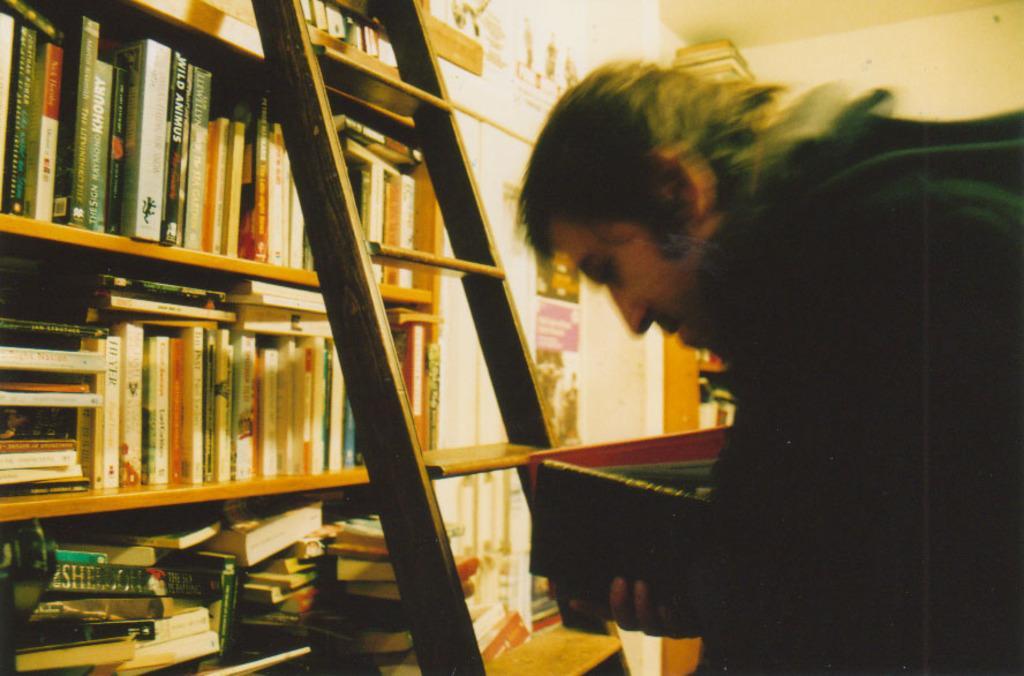Could you give a brief overview of what you see in this image? In this image we can see a person holding a book, in front of him we can see a ladder, there are some shelves with books and also we can see some posters on the wall. 